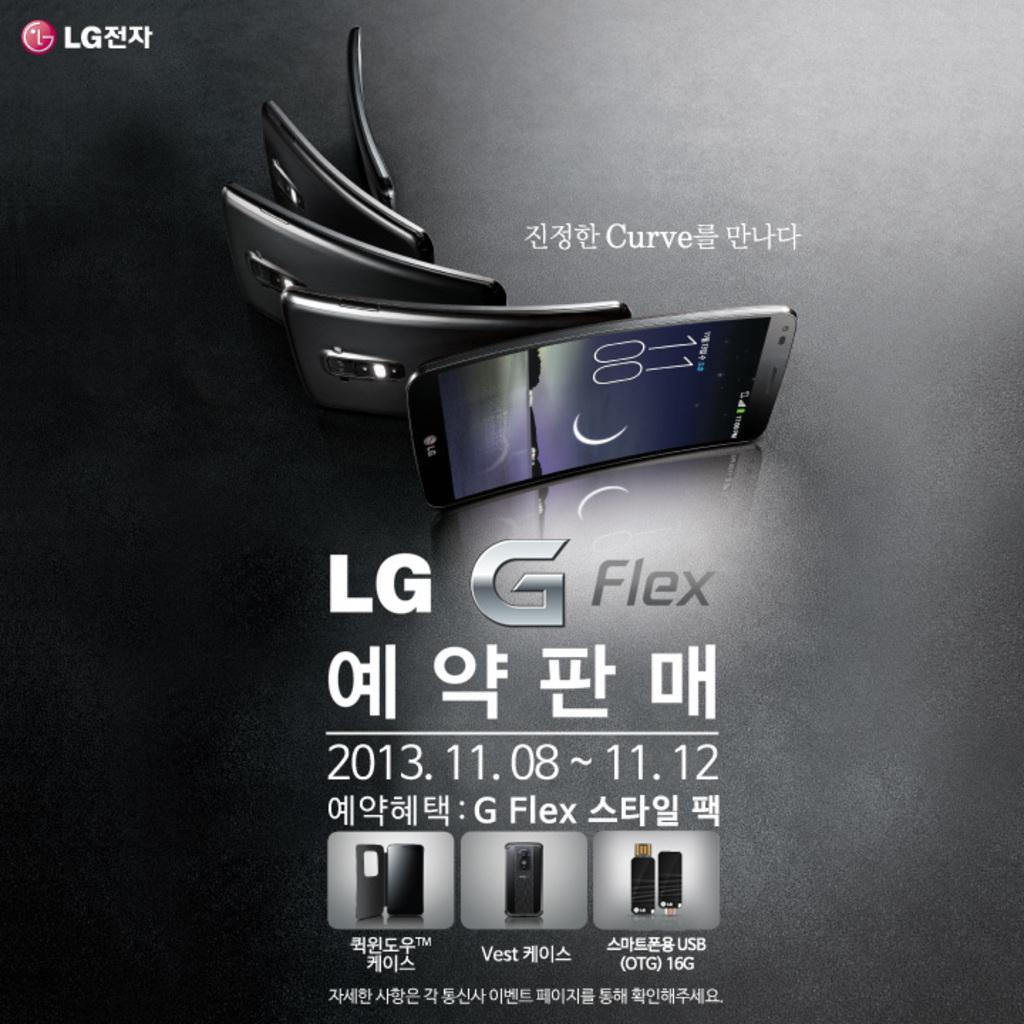<image>
Present a compact description of the photo's key features. An LG information poster advertisement shows a curved LG cell phone. 